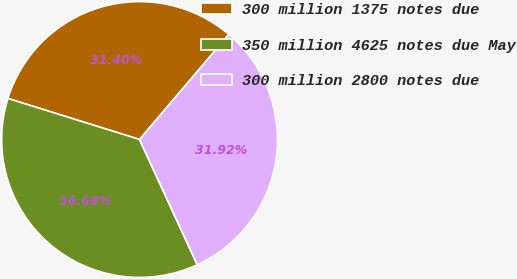<chart> <loc_0><loc_0><loc_500><loc_500><pie_chart><fcel>300 million 1375 notes due<fcel>350 million 4625 notes due May<fcel>300 million 2800 notes due<nl><fcel>31.4%<fcel>36.68%<fcel>31.92%<nl></chart> 